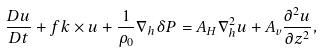<formula> <loc_0><loc_0><loc_500><loc_500>\frac { D { u } } { D t } + f { k } \times { u } + \frac { 1 } { \rho _ { 0 } } \nabla _ { h } \delta P = A _ { H } \nabla _ { h } ^ { 2 } { u } + A _ { v } \frac { \partial ^ { 2 } { u } } { \partial z ^ { 2 } } ,</formula> 